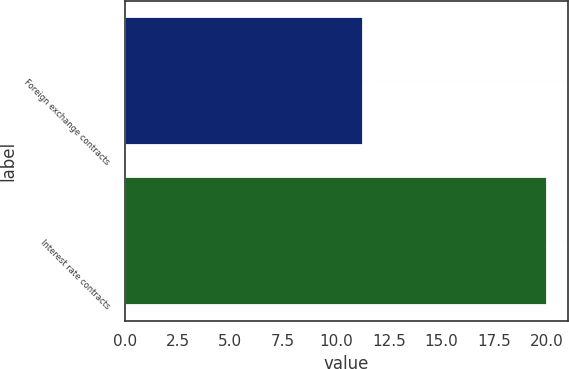Convert chart to OTSL. <chart><loc_0><loc_0><loc_500><loc_500><bar_chart><fcel>Foreign exchange contracts<fcel>Interest rate contracts<nl><fcel>11.3<fcel>20<nl></chart> 